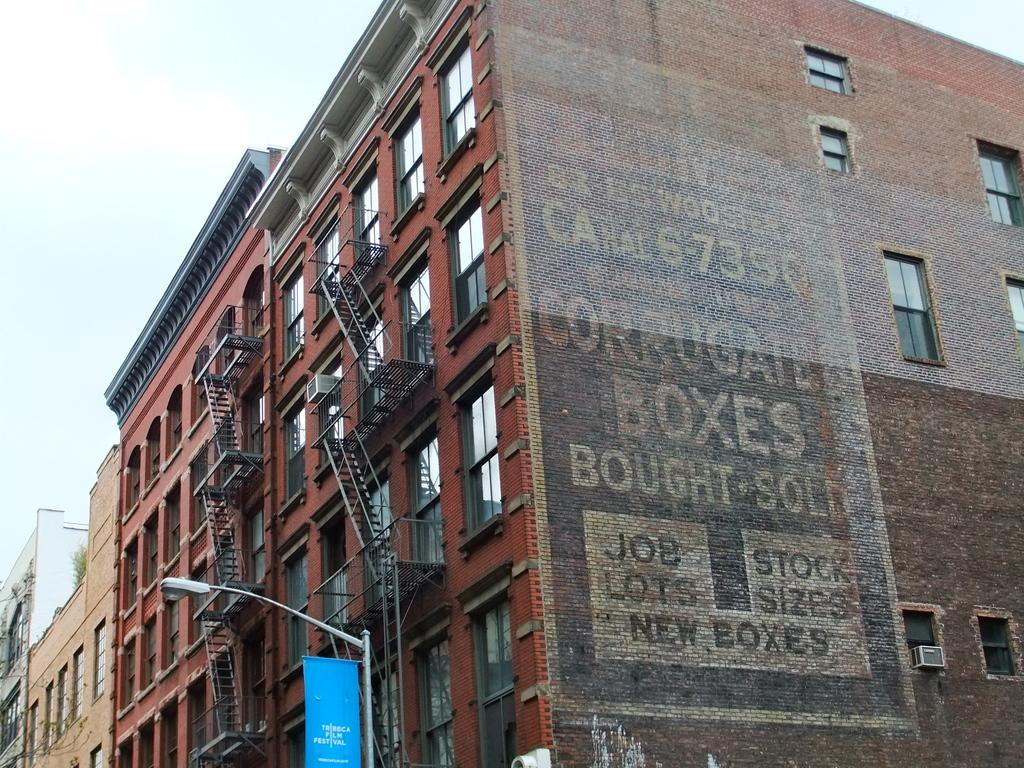What type of structures are present in the image? There are buildings in the image. What features can be seen on the buildings? The buildings have doors and windows. Is there any text visible in the image? Yes, there is text on a wall in the image. What type of lighting is present in the image? There is a street light with a board in the image. What is visible at the top of the image? The sky is visible at the top of the image. What committee is responsible for maintaining the buildings in the image? There is no information about a committee in the image, as it only shows buildings, doors, windows, text on a wall, a street light with a board, and the sky. 